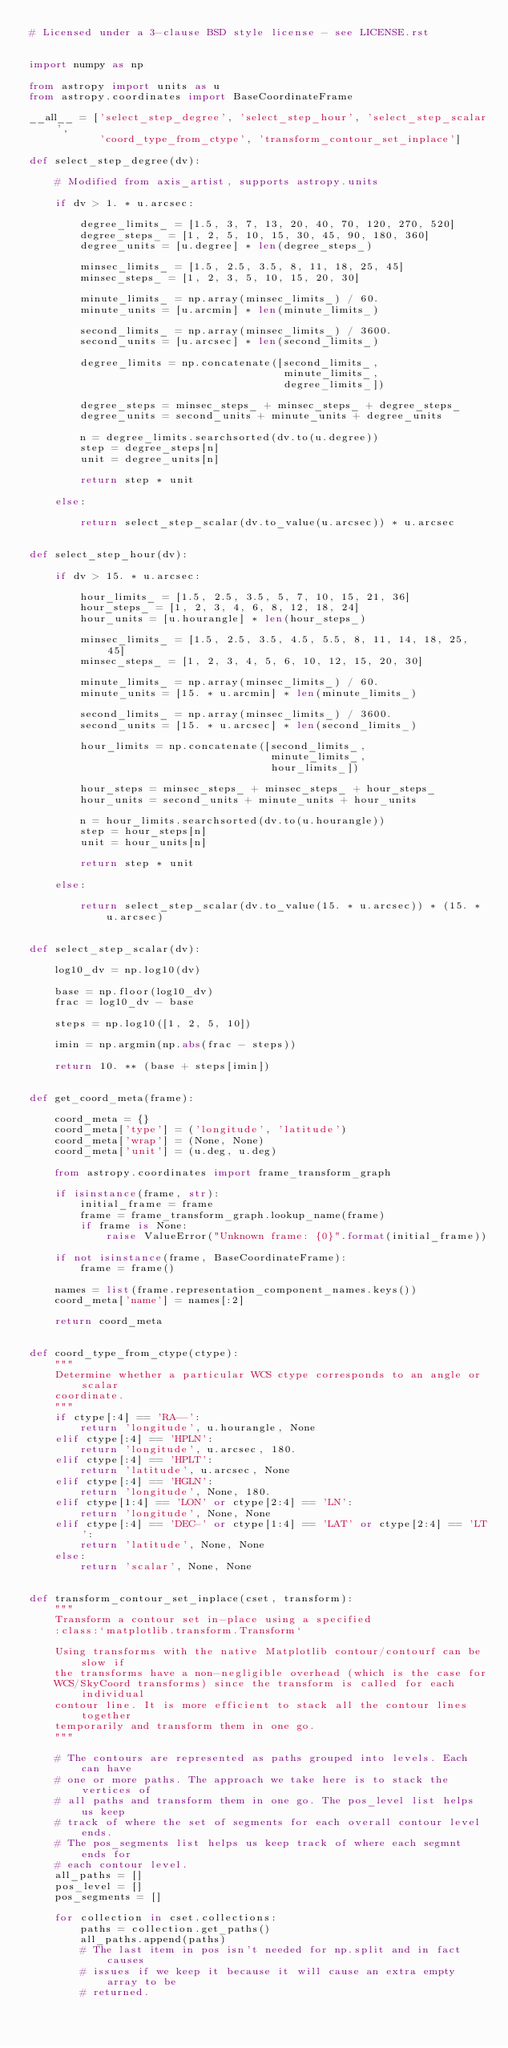<code> <loc_0><loc_0><loc_500><loc_500><_Python_># Licensed under a 3-clause BSD style license - see LICENSE.rst


import numpy as np

from astropy import units as u
from astropy.coordinates import BaseCoordinateFrame

__all__ = ['select_step_degree', 'select_step_hour', 'select_step_scalar',
           'coord_type_from_ctype', 'transform_contour_set_inplace']

def select_step_degree(dv):

    # Modified from axis_artist, supports astropy.units

    if dv > 1. * u.arcsec:

        degree_limits_ = [1.5, 3, 7, 13, 20, 40, 70, 120, 270, 520]
        degree_steps_ = [1, 2, 5, 10, 15, 30, 45, 90, 180, 360]
        degree_units = [u.degree] * len(degree_steps_)

        minsec_limits_ = [1.5, 2.5, 3.5, 8, 11, 18, 25, 45]
        minsec_steps_ = [1, 2, 3, 5, 10, 15, 20, 30]

        minute_limits_ = np.array(minsec_limits_) / 60.
        minute_units = [u.arcmin] * len(minute_limits_)

        second_limits_ = np.array(minsec_limits_) / 3600.
        second_units = [u.arcsec] * len(second_limits_)

        degree_limits = np.concatenate([second_limits_,
                                        minute_limits_,
                                        degree_limits_])

        degree_steps = minsec_steps_ + minsec_steps_ + degree_steps_
        degree_units = second_units + minute_units + degree_units

        n = degree_limits.searchsorted(dv.to(u.degree))
        step = degree_steps[n]
        unit = degree_units[n]

        return step * unit

    else:

        return select_step_scalar(dv.to_value(u.arcsec)) * u.arcsec


def select_step_hour(dv):

    if dv > 15. * u.arcsec:

        hour_limits_ = [1.5, 2.5, 3.5, 5, 7, 10, 15, 21, 36]
        hour_steps_ = [1, 2, 3, 4, 6, 8, 12, 18, 24]
        hour_units = [u.hourangle] * len(hour_steps_)

        minsec_limits_ = [1.5, 2.5, 3.5, 4.5, 5.5, 8, 11, 14, 18, 25, 45]
        minsec_steps_ = [1, 2, 3, 4, 5, 6, 10, 12, 15, 20, 30]

        minute_limits_ = np.array(minsec_limits_) / 60.
        minute_units = [15. * u.arcmin] * len(minute_limits_)

        second_limits_ = np.array(minsec_limits_) / 3600.
        second_units = [15. * u.arcsec] * len(second_limits_)

        hour_limits = np.concatenate([second_limits_,
                                      minute_limits_,
                                      hour_limits_])

        hour_steps = minsec_steps_ + minsec_steps_ + hour_steps_
        hour_units = second_units + minute_units + hour_units

        n = hour_limits.searchsorted(dv.to(u.hourangle))
        step = hour_steps[n]
        unit = hour_units[n]

        return step * unit

    else:

        return select_step_scalar(dv.to_value(15. * u.arcsec)) * (15. * u.arcsec)


def select_step_scalar(dv):

    log10_dv = np.log10(dv)

    base = np.floor(log10_dv)
    frac = log10_dv - base

    steps = np.log10([1, 2, 5, 10])

    imin = np.argmin(np.abs(frac - steps))

    return 10. ** (base + steps[imin])


def get_coord_meta(frame):

    coord_meta = {}
    coord_meta['type'] = ('longitude', 'latitude')
    coord_meta['wrap'] = (None, None)
    coord_meta['unit'] = (u.deg, u.deg)

    from astropy.coordinates import frame_transform_graph

    if isinstance(frame, str):
        initial_frame = frame
        frame = frame_transform_graph.lookup_name(frame)
        if frame is None:
            raise ValueError("Unknown frame: {0}".format(initial_frame))

    if not isinstance(frame, BaseCoordinateFrame):
        frame = frame()

    names = list(frame.representation_component_names.keys())
    coord_meta['name'] = names[:2]

    return coord_meta


def coord_type_from_ctype(ctype):
    """
    Determine whether a particular WCS ctype corresponds to an angle or scalar
    coordinate.
    """
    if ctype[:4] == 'RA--':
        return 'longitude', u.hourangle, None
    elif ctype[:4] == 'HPLN':
        return 'longitude', u.arcsec, 180.
    elif ctype[:4] == 'HPLT':
        return 'latitude', u.arcsec, None
    elif ctype[:4] == 'HGLN':
        return 'longitude', None, 180.
    elif ctype[1:4] == 'LON' or ctype[2:4] == 'LN':
        return 'longitude', None, None
    elif ctype[:4] == 'DEC-' or ctype[1:4] == 'LAT' or ctype[2:4] == 'LT':
        return 'latitude', None, None
    else:
        return 'scalar', None, None


def transform_contour_set_inplace(cset, transform):
    """
    Transform a contour set in-place using a specified
    :class:`matplotlib.transform.Transform`

    Using transforms with the native Matplotlib contour/contourf can be slow if
    the transforms have a non-negligible overhead (which is the case for
    WCS/SkyCoord transforms) since the transform is called for each individual
    contour line. It is more efficient to stack all the contour lines together
    temporarily and transform them in one go.
    """

    # The contours are represented as paths grouped into levels. Each can have
    # one or more paths. The approach we take here is to stack the vertices of
    # all paths and transform them in one go. The pos_level list helps us keep
    # track of where the set of segments for each overall contour level ends.
    # The pos_segments list helps us keep track of where each segmnt ends for
    # each contour level.
    all_paths = []
    pos_level = []
    pos_segments = []

    for collection in cset.collections:
        paths = collection.get_paths()
        all_paths.append(paths)
        # The last item in pos isn't needed for np.split and in fact causes
        # issues if we keep it because it will cause an extra empty array to be
        # returned.</code> 